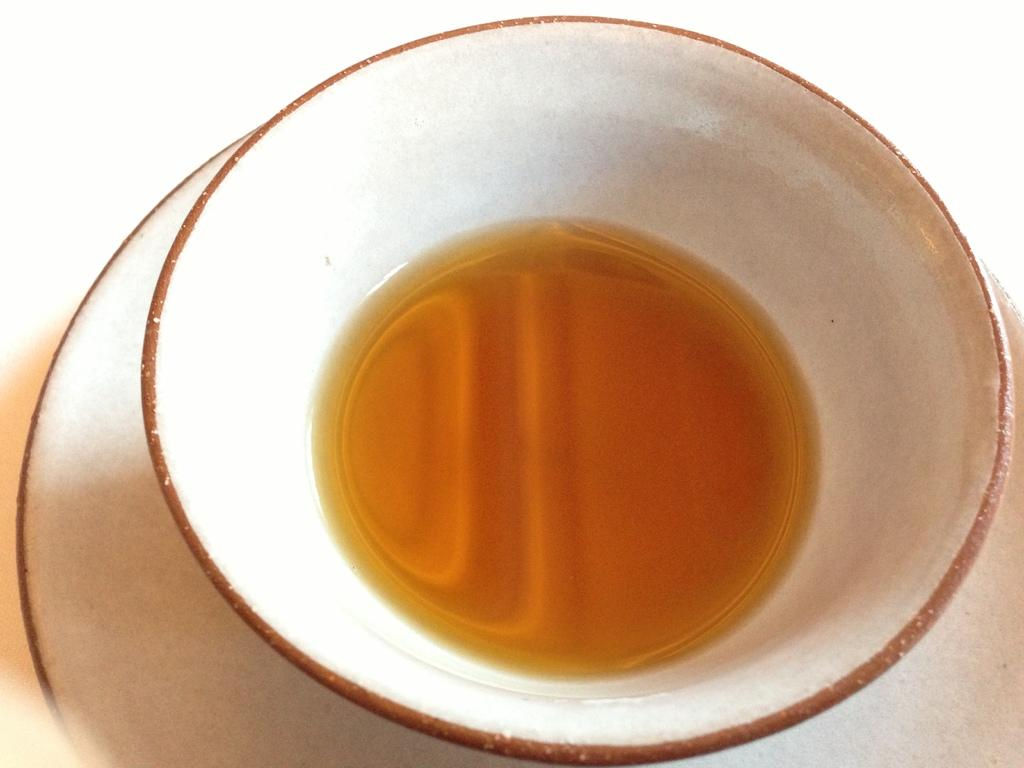What is in the bowl that is visible in the image? The bowl contains a drink. What is the bowl resting on in the image? The bowl is placed on a saucer. What type of waves can be seen crashing on the shore in the image? There are no waves or shore visible in the image; it features a bowl with a drink placed on a saucer. 